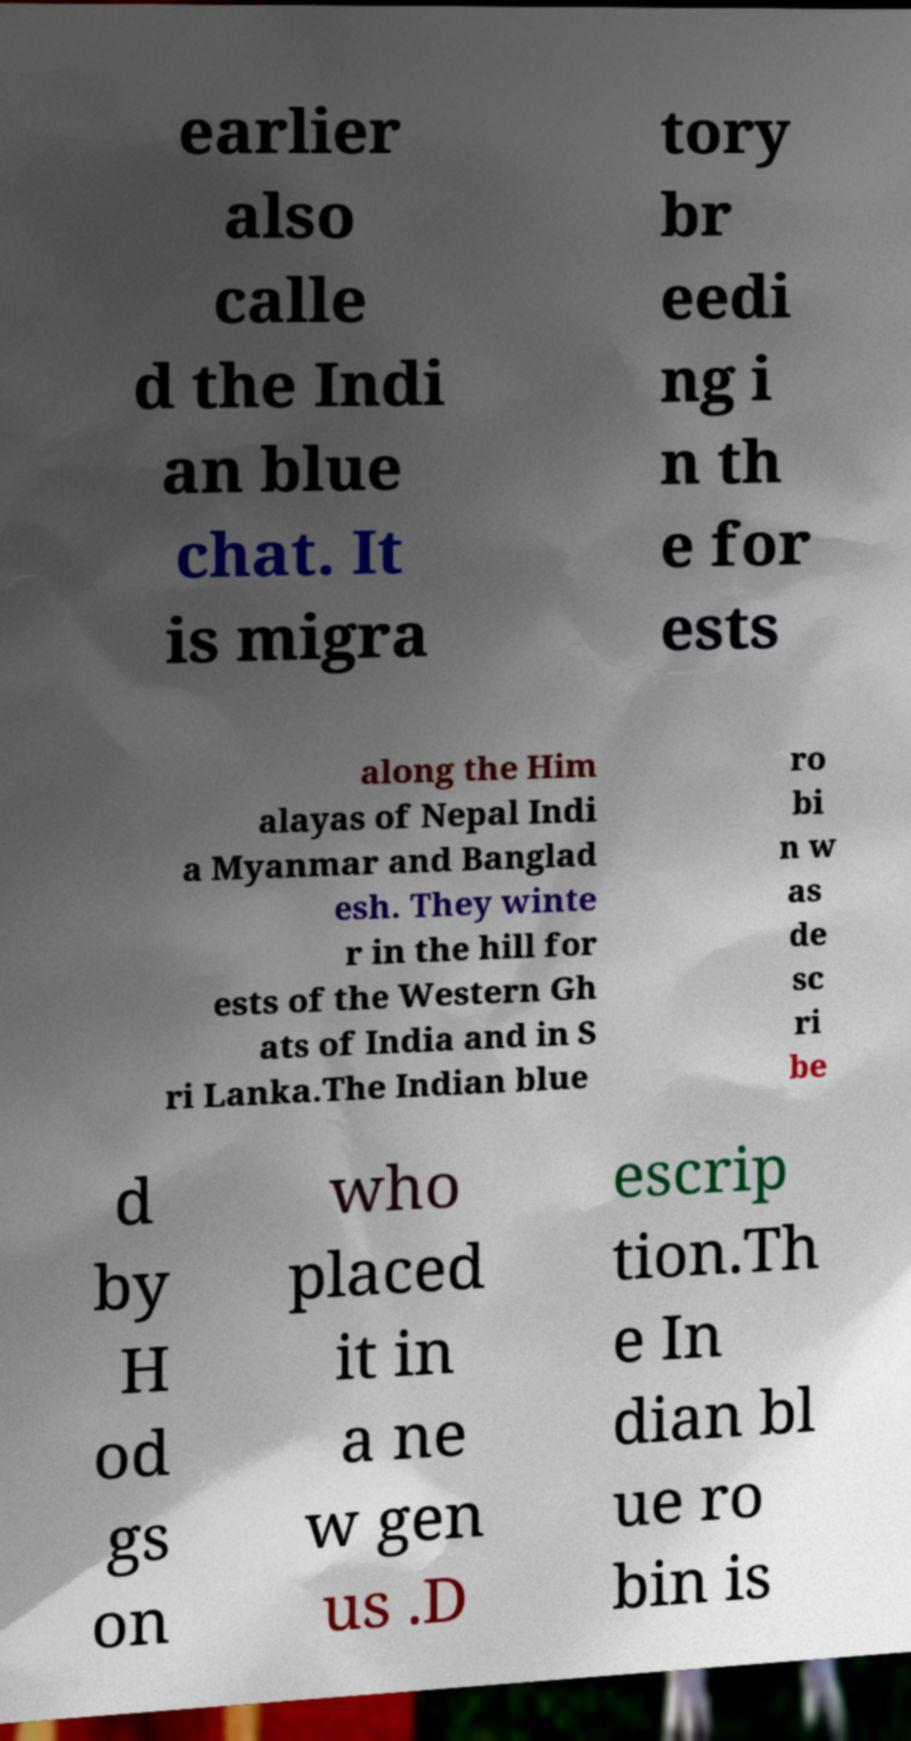I need the written content from this picture converted into text. Can you do that? earlier also calle d the Indi an blue chat. It is migra tory br eedi ng i n th e for ests along the Him alayas of Nepal Indi a Myanmar and Banglad esh. They winte r in the hill for ests of the Western Gh ats of India and in S ri Lanka.The Indian blue ro bi n w as de sc ri be d by H od gs on who placed it in a ne w gen us .D escrip tion.Th e In dian bl ue ro bin is 